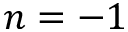Convert formula to latex. <formula><loc_0><loc_0><loc_500><loc_500>n = - 1</formula> 